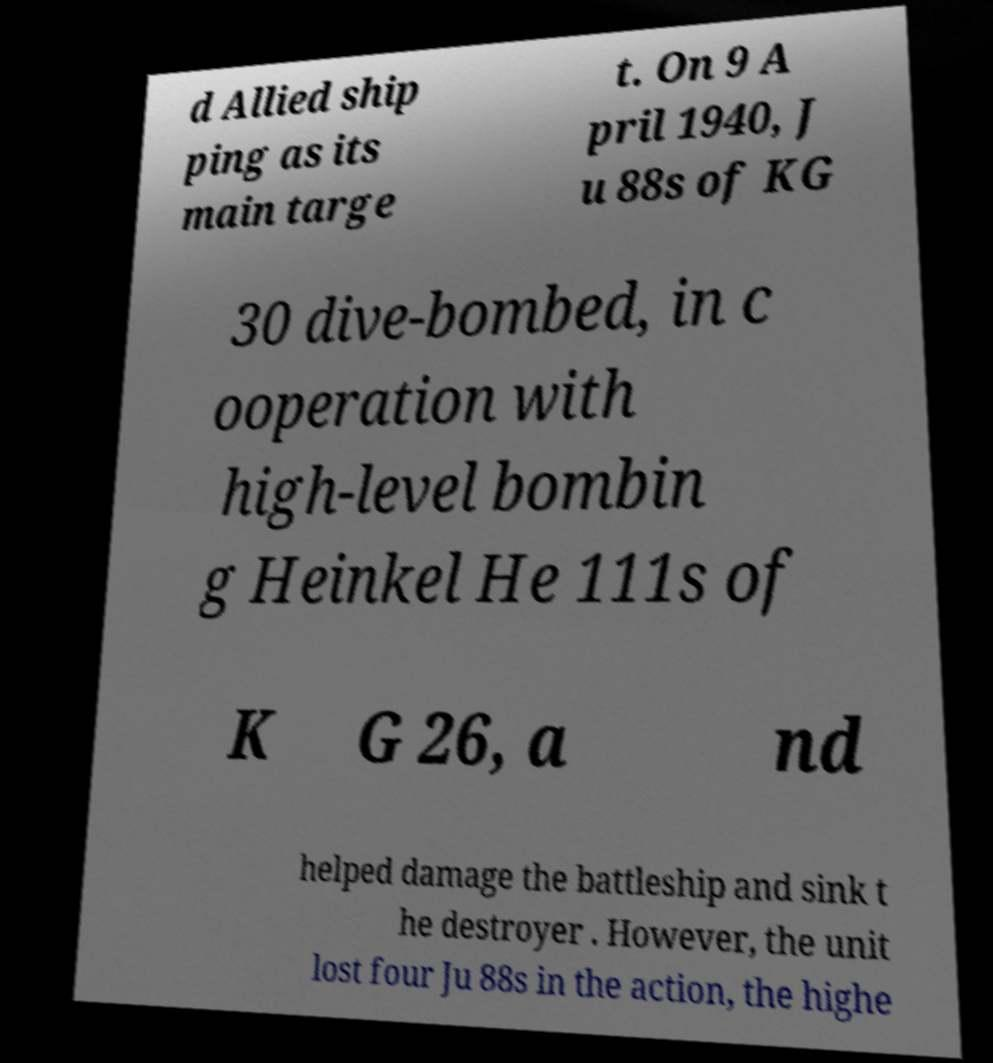There's text embedded in this image that I need extracted. Can you transcribe it verbatim? d Allied ship ping as its main targe t. On 9 A pril 1940, J u 88s of KG 30 dive-bombed, in c ooperation with high-level bombin g Heinkel He 111s of K G 26, a nd helped damage the battleship and sink t he destroyer . However, the unit lost four Ju 88s in the action, the highe 